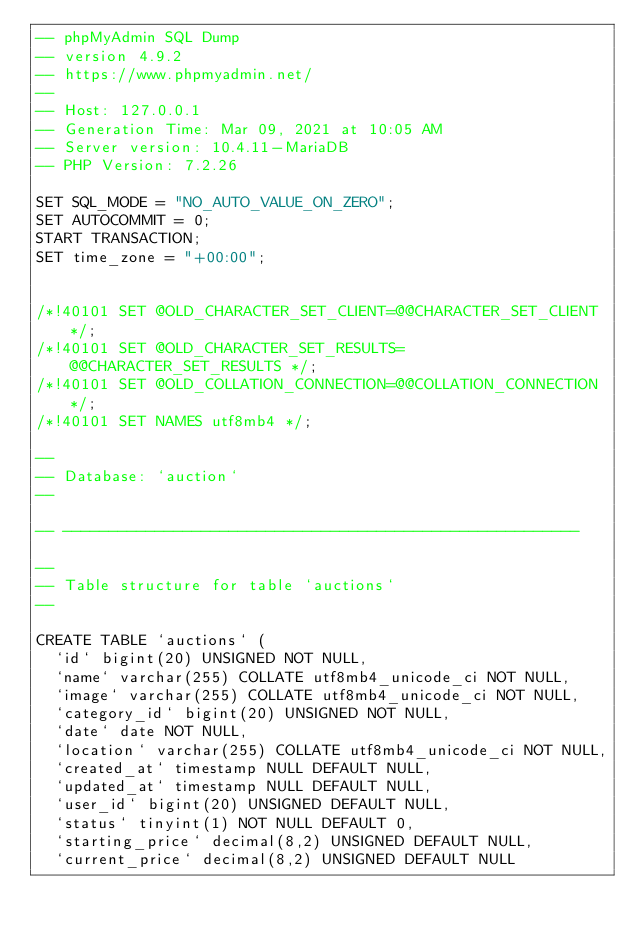Convert code to text. <code><loc_0><loc_0><loc_500><loc_500><_SQL_>-- phpMyAdmin SQL Dump
-- version 4.9.2
-- https://www.phpmyadmin.net/
--
-- Host: 127.0.0.1
-- Generation Time: Mar 09, 2021 at 10:05 AM
-- Server version: 10.4.11-MariaDB
-- PHP Version: 7.2.26

SET SQL_MODE = "NO_AUTO_VALUE_ON_ZERO";
SET AUTOCOMMIT = 0;
START TRANSACTION;
SET time_zone = "+00:00";


/*!40101 SET @OLD_CHARACTER_SET_CLIENT=@@CHARACTER_SET_CLIENT */;
/*!40101 SET @OLD_CHARACTER_SET_RESULTS=@@CHARACTER_SET_RESULTS */;
/*!40101 SET @OLD_COLLATION_CONNECTION=@@COLLATION_CONNECTION */;
/*!40101 SET NAMES utf8mb4 */;

--
-- Database: `auction`
--

-- --------------------------------------------------------

--
-- Table structure for table `auctions`
--

CREATE TABLE `auctions` (
  `id` bigint(20) UNSIGNED NOT NULL,
  `name` varchar(255) COLLATE utf8mb4_unicode_ci NOT NULL,
  `image` varchar(255) COLLATE utf8mb4_unicode_ci NOT NULL,
  `category_id` bigint(20) UNSIGNED NOT NULL,
  `date` date NOT NULL,
  `location` varchar(255) COLLATE utf8mb4_unicode_ci NOT NULL,
  `created_at` timestamp NULL DEFAULT NULL,
  `updated_at` timestamp NULL DEFAULT NULL,
  `user_id` bigint(20) UNSIGNED DEFAULT NULL,
  `status` tinyint(1) NOT NULL DEFAULT 0,
  `starting_price` decimal(8,2) UNSIGNED DEFAULT NULL,
  `current_price` decimal(8,2) UNSIGNED DEFAULT NULL</code> 